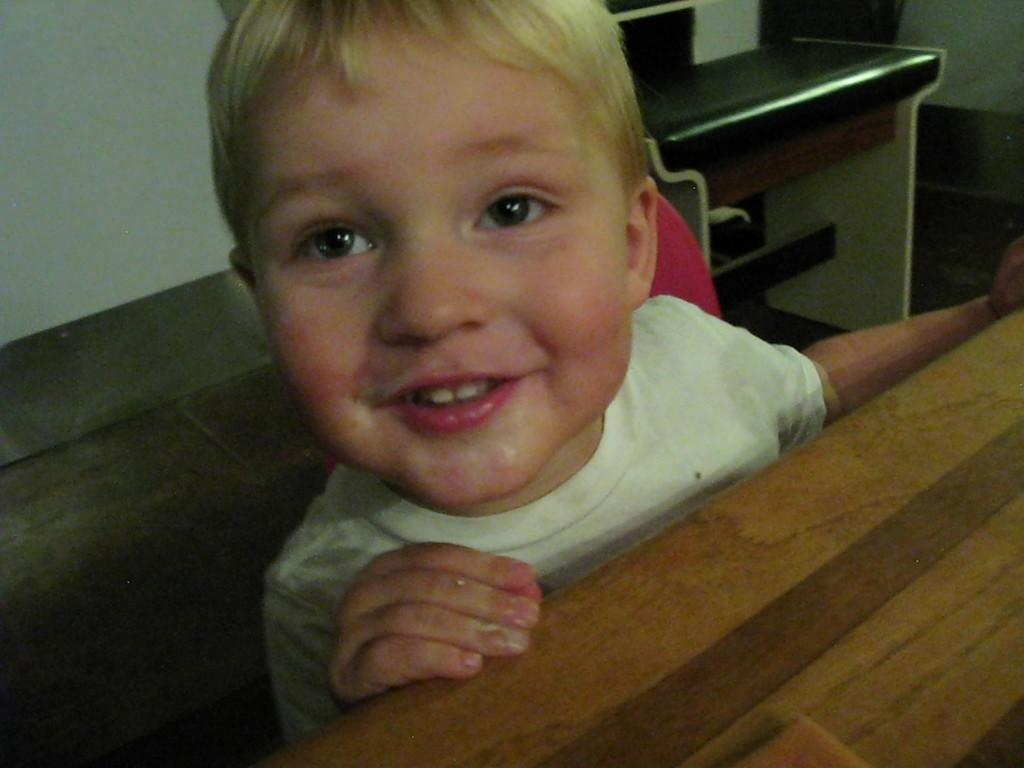Who is present in the image? There is a boy in the image. What is the boy's facial expression? The boy is smiling. What is the boy's position in the image? The boy is sitting on a chair. What objects are in front of and behind the boy? There is a table in front of the boy and another table behind him. What can be seen in the background of the image? There is a wall visible in the background of the image. How many tickets does the boy have in his hand in the image? There is no mention of tickets in the image, so it cannot be determined if the boy has any. 